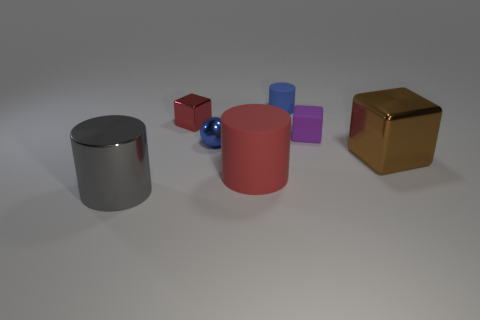How does the lighting in the scene affect the appearance of the objects? The lighting in the scene casts soft shadows behind the objects, which gives a sense of depth and positioning. It also highlights the textures and reflects off the metallic surfaces, such as the blue sphere and cylindrical objects, emphasizing their shiny material. 